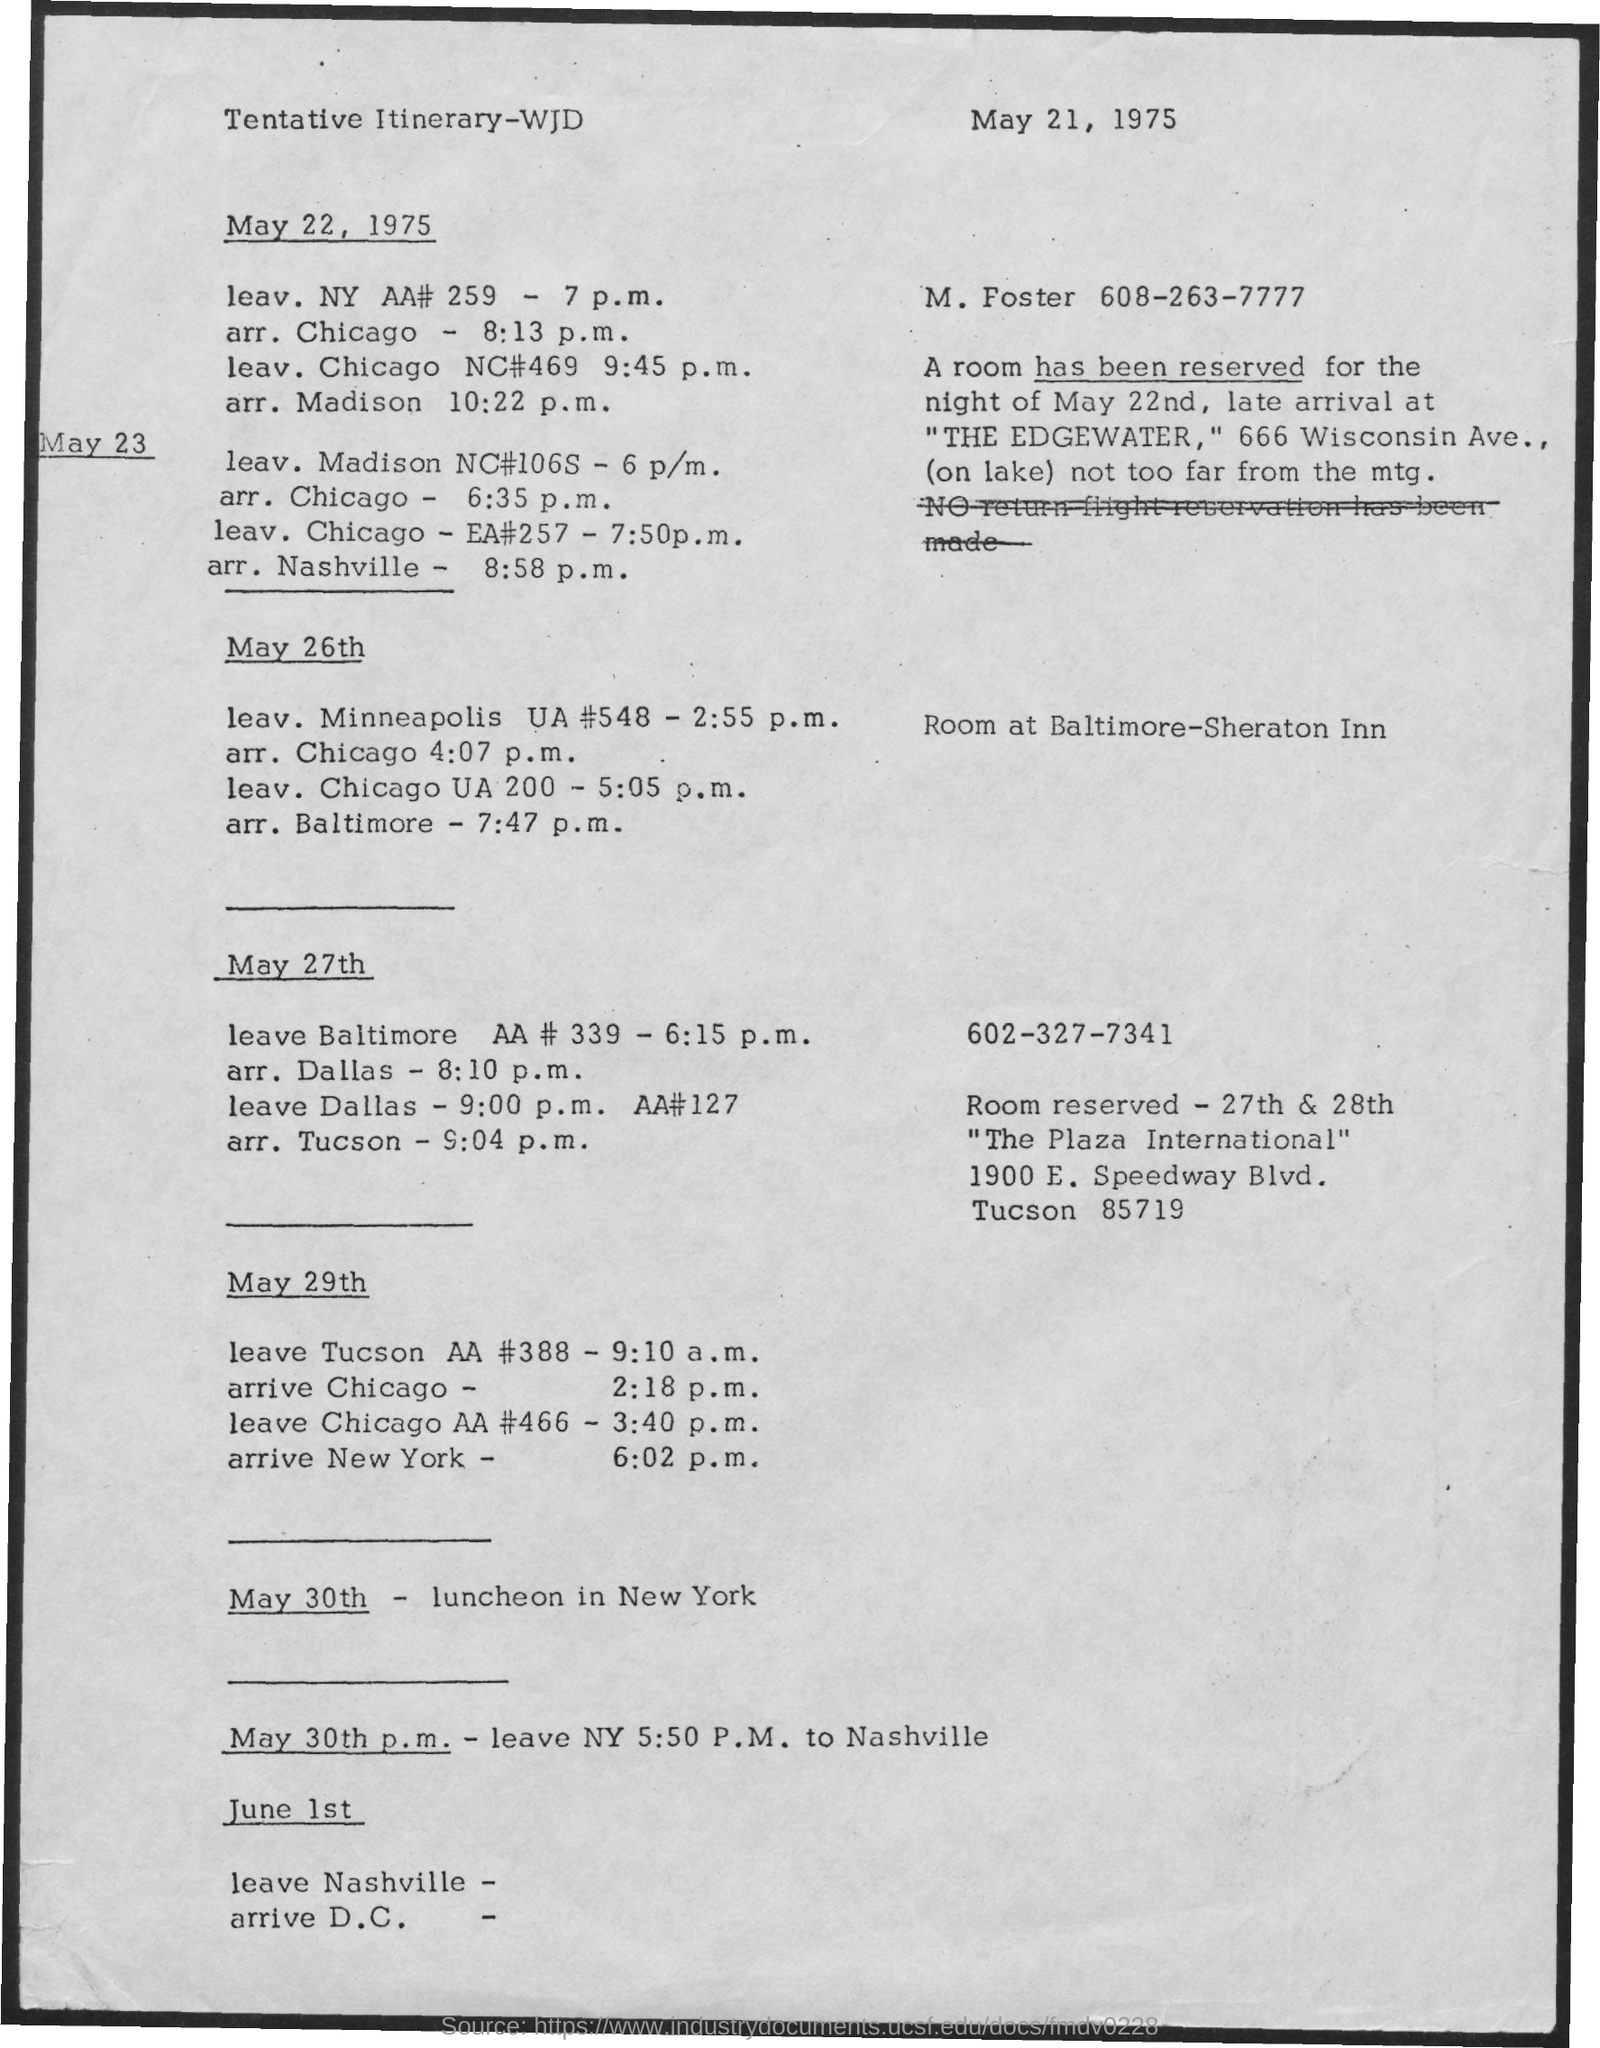Outline some significant characteristics in this image. The luncheon in New York is scheduled for May 30th. 